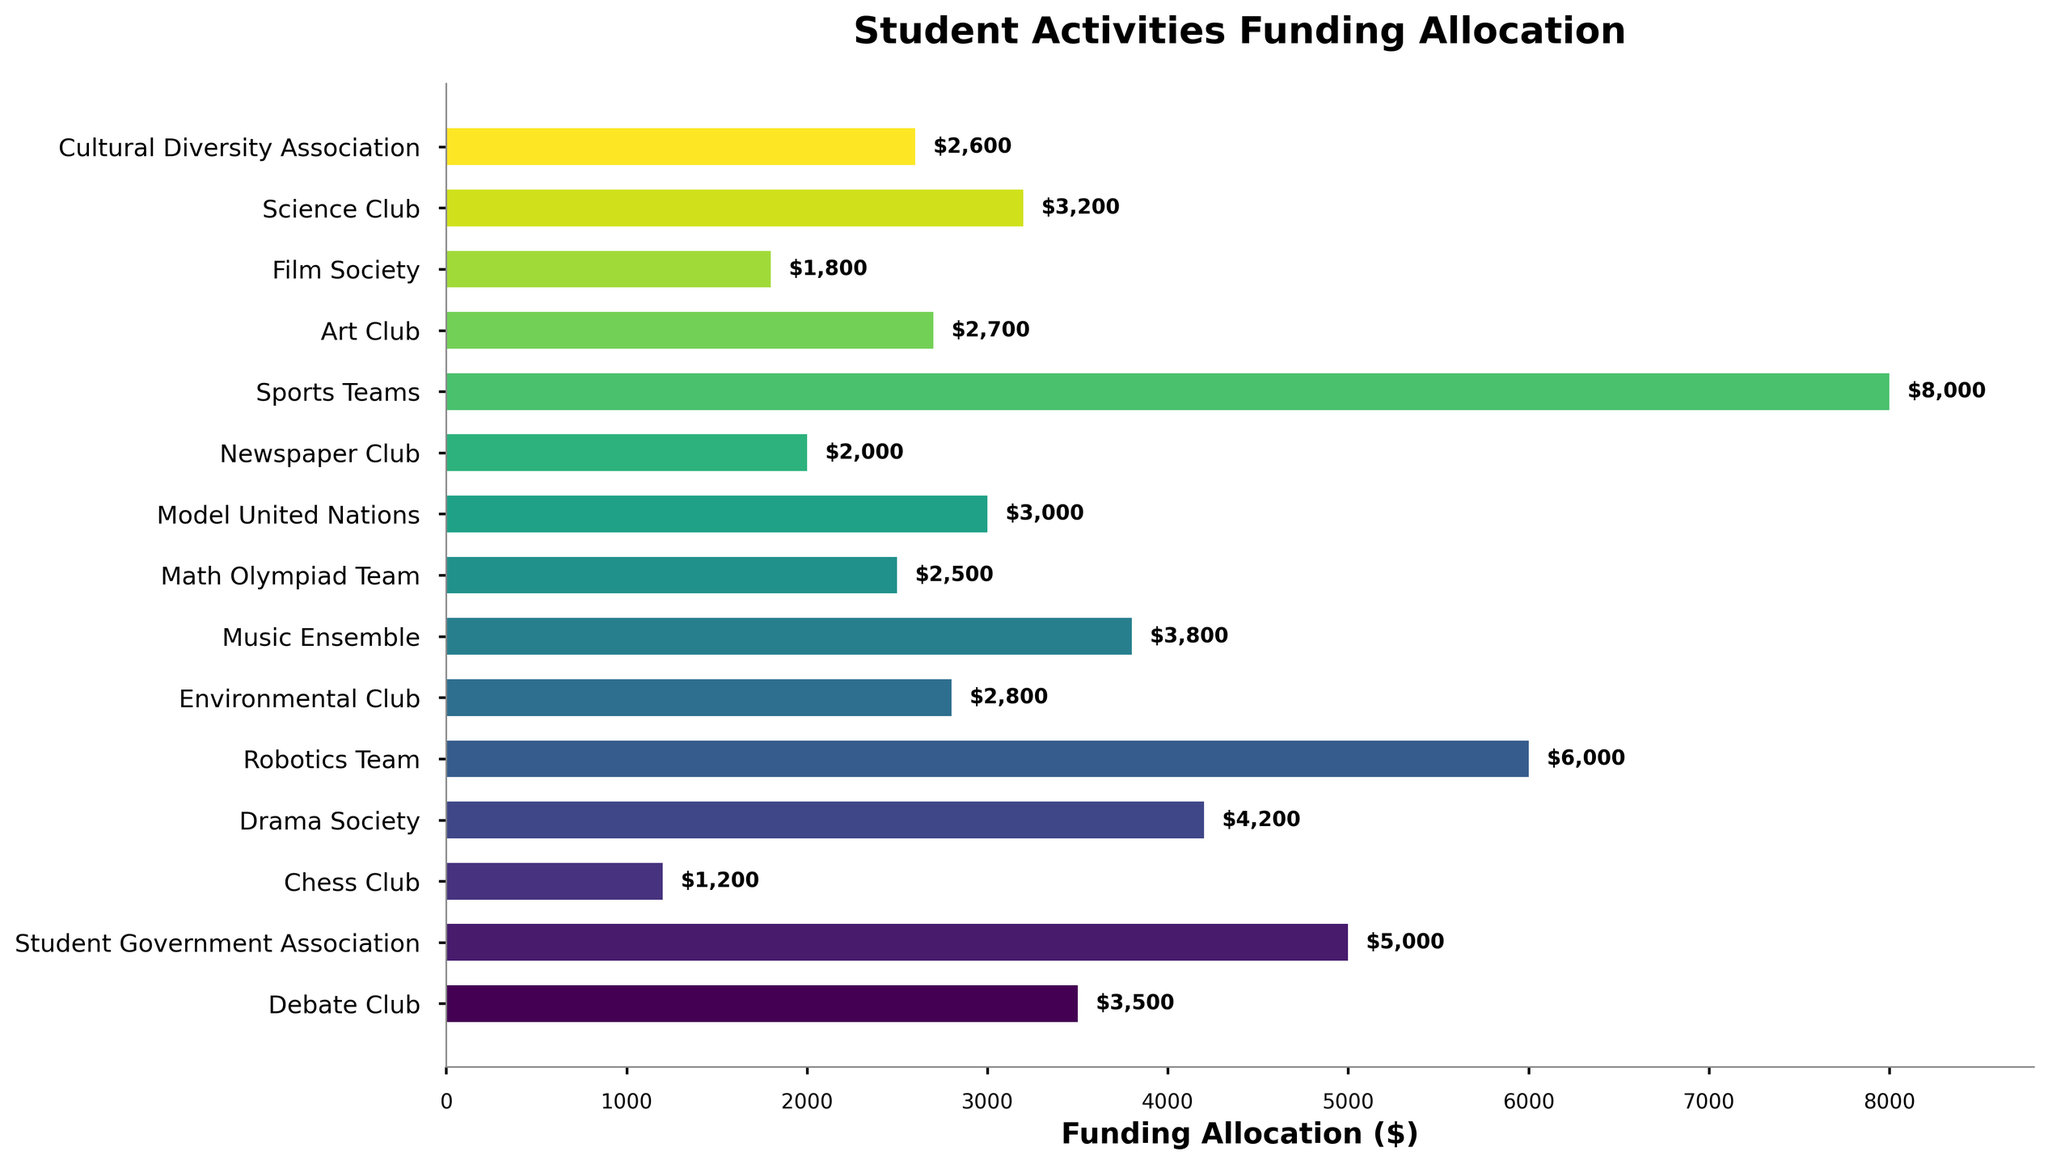Which club received the highest funding allocation? By examining the length of the bars and the funding values, we see that the Sports Teams received the highest funding allocation.
Answer: Sports Teams How much more funding did the Robotics Team receive compared to the Debate Club? The Robotics Team received $6000, and the Debate Club received $3500. Subtracting these values gives $6000 - $3500 = $2500.
Answer: $2500 Which club received the least funding, and how much did they receive? By looking for the shortest bar, we see that the Chess Club received the least funding with $1200.
Answer: Chess Club, $1200 What is the combined funding allocation for the Drama Society and the Music Ensemble? Adding the funding allocations for Drama Society ($4200) and Music Ensemble ($3800) gives $4200 + $3800 = $8000.
Answer: $8000 Are there any clubs that received the same amount of funding? Upon reviewing the bars and the corresponding funding amounts, no two clubs received the same amount.
Answer: No Which club is positioned exactly in the middle in terms of the funding allocation amount? Arranging the clubs by their funding amounts, Cultural Diversity Association is positioned in the middle with $2600.
Answer: Cultural Diversity Association What was the total funding allocation for all clubs combined? Summing all the funding allocations: $3500 + $5000 + $1200 + $4200 + $6000 + $2800 + $3800 + $2500 + $3000 + $2000 + $8000 + $2700 + $1800 + $3200 + $2600 = $55300.
Answer: $55300 How much more funding did the Student Government Association receive compared to the Science Club? The Student Government Association received $5000, and the Science Club received $3200. Subtracting these values gives $5000 - $3200 = $1800.
Answer: $1800 What percentage of the total funding was allocated to the Robotics Team? The total funding is $55300. The Robotics Team received $6000. The percentage is calculated as ($6000 / $55300) * 100 ≈ 10.85%.
Answer: 10.85% Which clubs received more funding than the Model United Nations but less than the Drama Society? To find clubs in the range $3000 < x < $4200, we identify the Science Club ($3200) and the Music Ensemble ($3800) received more than Model United Nations but less than Drama Society.
Answer: Science Club, Music Ensemble 